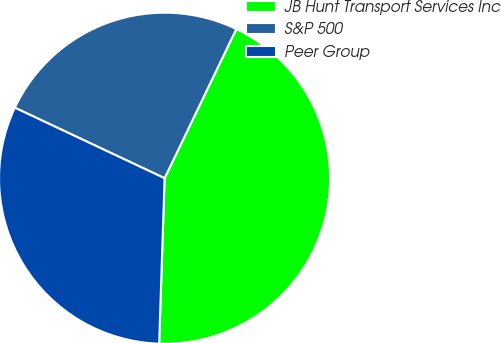Convert chart to OTSL. <chart><loc_0><loc_0><loc_500><loc_500><pie_chart><fcel>JB Hunt Transport Services Inc<fcel>S&P 500<fcel>Peer Group<nl><fcel>43.39%<fcel>25.12%<fcel>31.48%<nl></chart> 